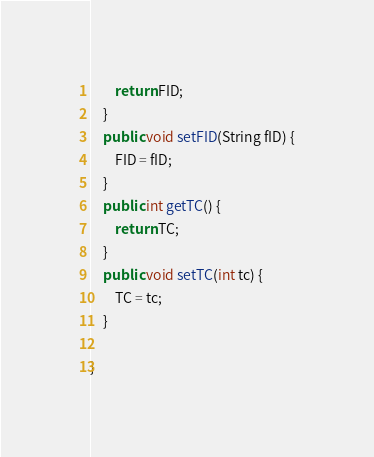Convert code to text. <code><loc_0><loc_0><loc_500><loc_500><_Java_>		return FID;
	}
	public void setFID(String fID) {
		FID = fID;
	}
	public int getTC() {
		return TC;
	}
	public void setTC(int tc) {
		TC = tc;
	}
	
}</code> 